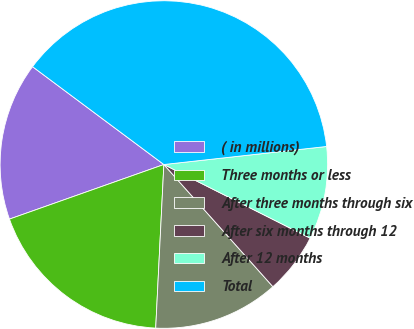<chart> <loc_0><loc_0><loc_500><loc_500><pie_chart><fcel>( in millions)<fcel>Three months or less<fcel>After three months through six<fcel>After six months through 12<fcel>After 12 months<fcel>Total<nl><fcel>15.6%<fcel>18.8%<fcel>12.39%<fcel>5.98%<fcel>9.18%<fcel>38.05%<nl></chart> 